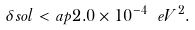<formula> <loc_0><loc_0><loc_500><loc_500>\delta s o l < a p 2 . 0 \times 1 0 ^ { - 4 } \ e V ^ { 2 } .</formula> 